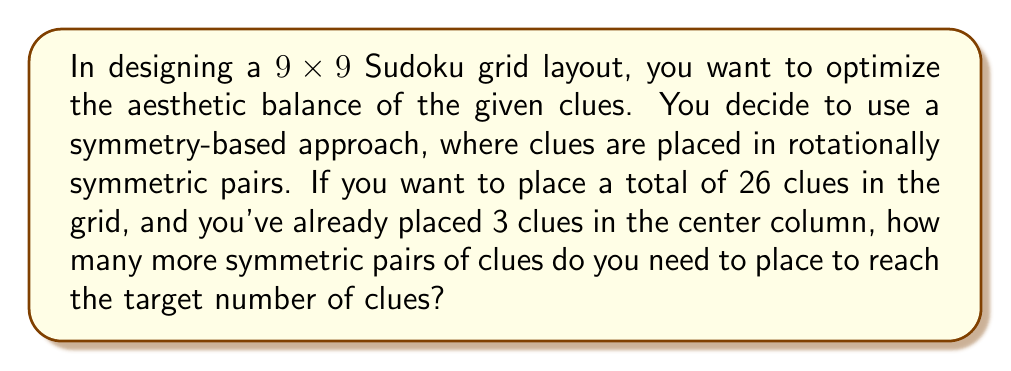Provide a solution to this math problem. Let's approach this step-by-step:

1) First, let's understand what rotationally symmetric pairs mean in a 9x9 Sudoku grid:
   - For every clue placed in position (x, y), its symmetric pair would be at (9-x+1, 9-y+1).
   - The center cell (5, 5) is its own symmetric pair.

2) Now, let's count the clues we already have:
   - 3 clues in the center column

3) Let's consider how many of these existing clues form symmetric pairs:
   - If one of the 3 clues is in the center cell (5, 5), it forms its own pair.
   - The other two would form a symmetric pair with each other.
   - So, these 3 clues effectively count as 2 pairs.

4) Calculate the remaining clues to be placed:
   - Total clues needed: 26
   - Clues already placed: 3
   - Remaining clues: 26 - 3 = 23

5) Calculate the number of symmetric pairs needed:
   - Each pair adds 2 clues
   - Number of pairs = Remaining clues ÷ 2
   - Number of pairs = 23 ÷ 2 = 11.5

6) Since we can't place half a pair, we round up to the nearest whole number:
   - Number of symmetric pairs to place = 12

Therefore, you need to place 12 more symmetric pairs of clues to reach the target of 26 total clues while maintaining rotational symmetry.
Answer: 12 symmetric pairs 